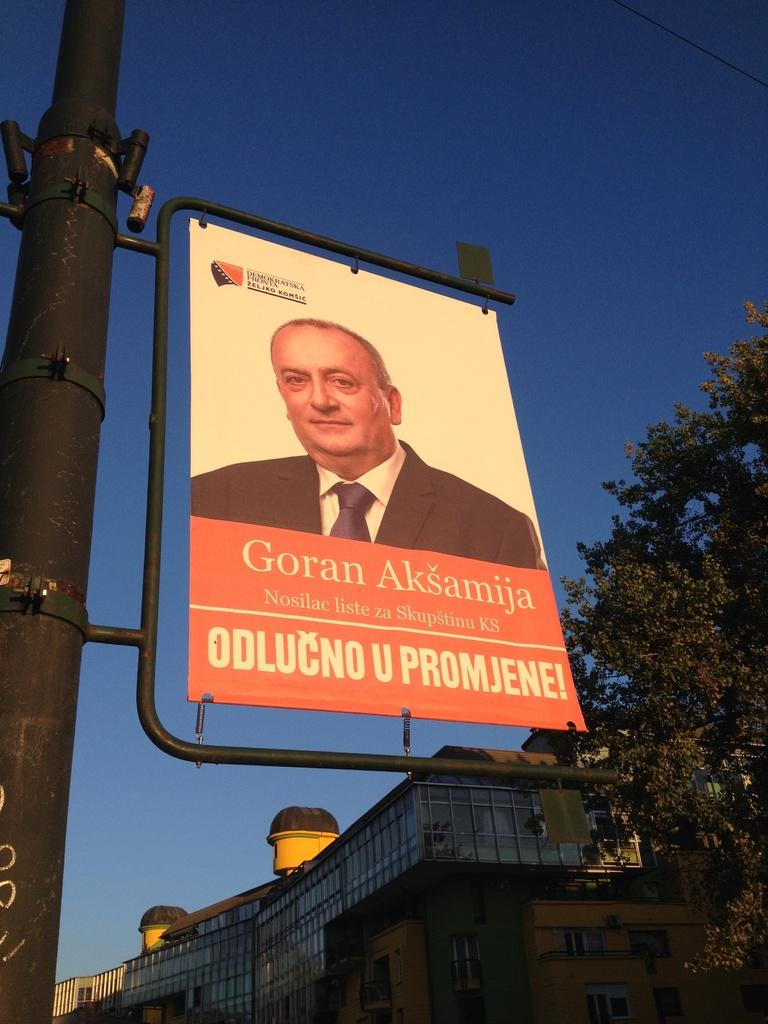<image>
Present a compact description of the photo's key features. A large banner mounted a pole bears the image of a person named Goran Aksamija. 